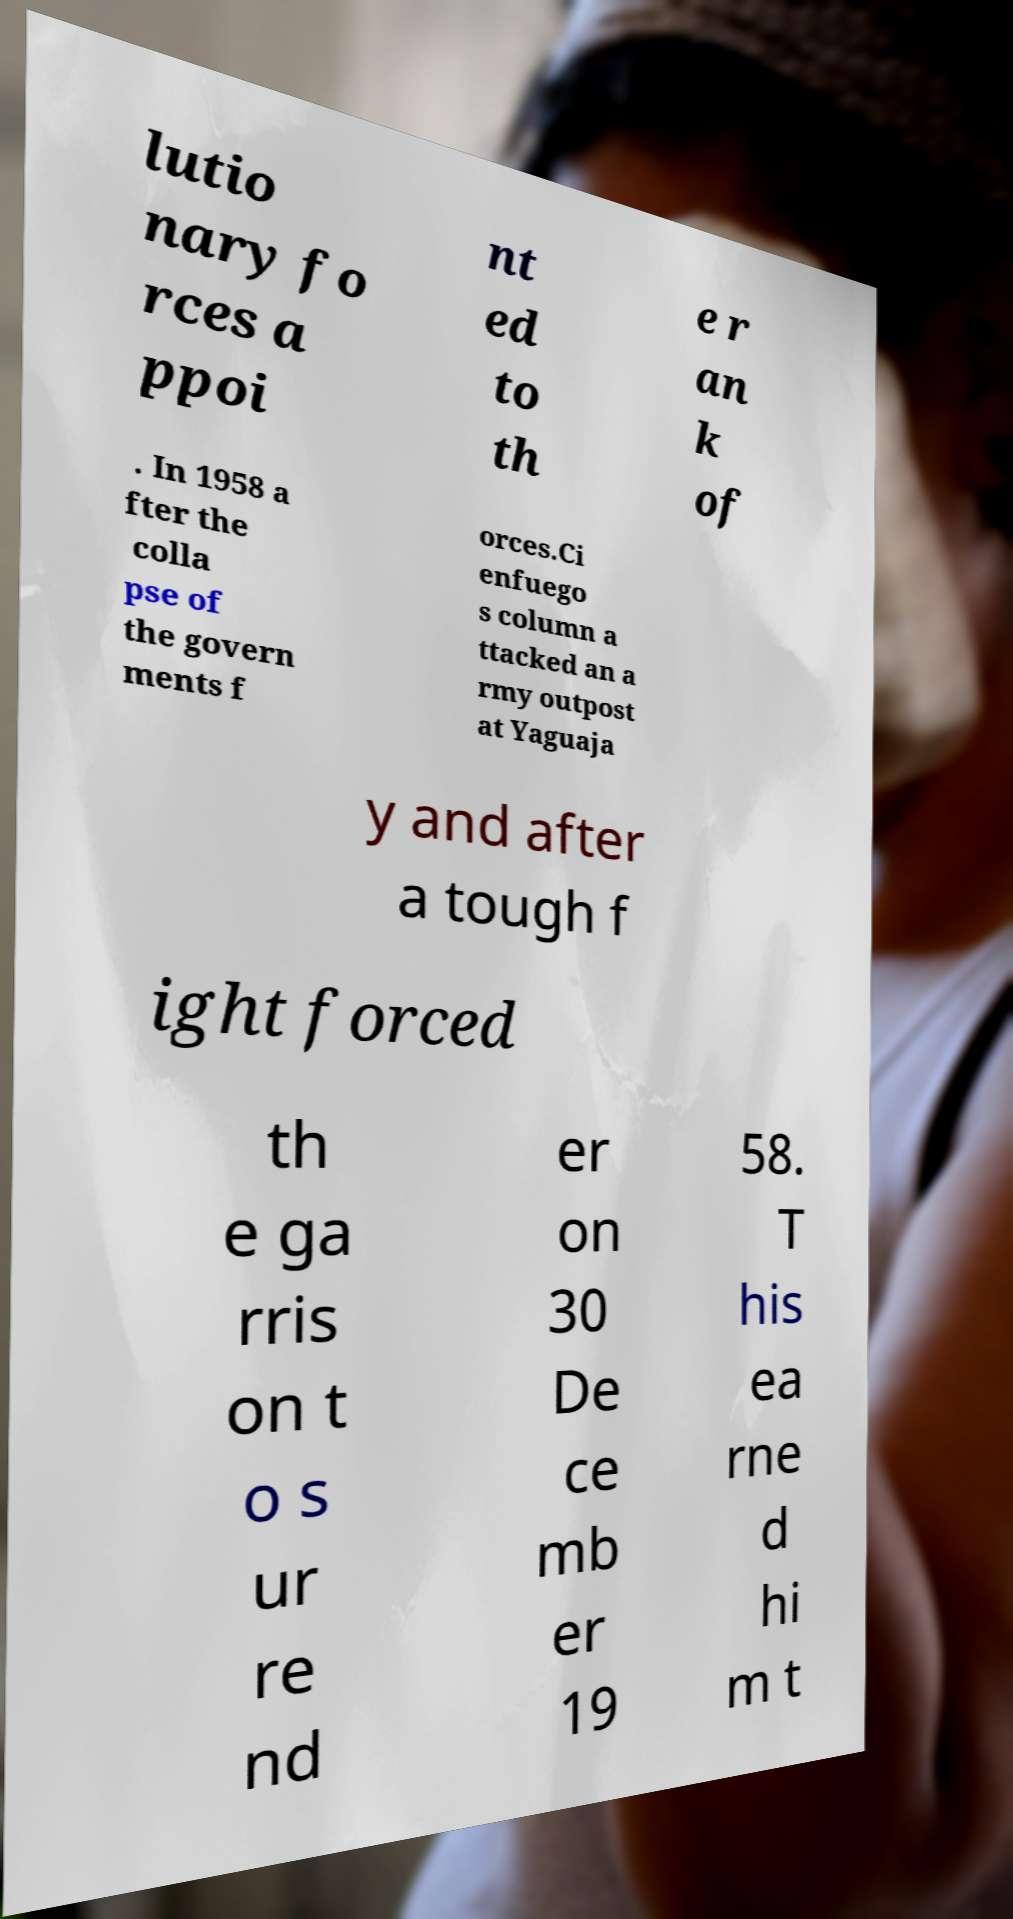Can you accurately transcribe the text from the provided image for me? lutio nary fo rces a ppoi nt ed to th e r an k of . In 1958 a fter the colla pse of the govern ments f orces.Ci enfuego s column a ttacked an a rmy outpost at Yaguaja y and after a tough f ight forced th e ga rris on t o s ur re nd er on 30 De ce mb er 19 58. T his ea rne d hi m t 